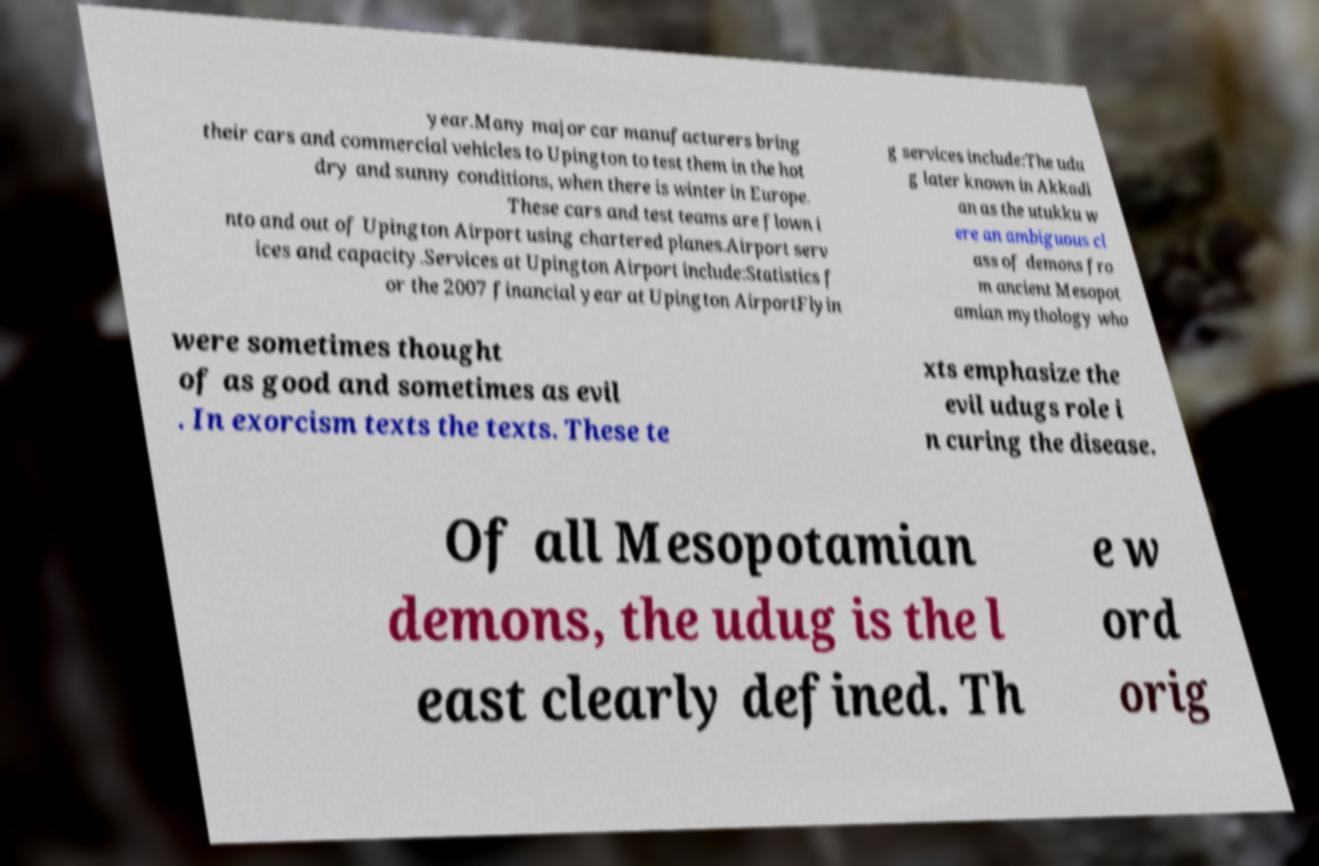For documentation purposes, I need the text within this image transcribed. Could you provide that? year.Many major car manufacturers bring their cars and commercial vehicles to Upington to test them in the hot dry and sunny conditions, when there is winter in Europe. These cars and test teams are flown i nto and out of Upington Airport using chartered planes.Airport serv ices and capacity.Services at Upington Airport include:Statistics f or the 2007 financial year at Upington AirportFlyin g services include:The udu g later known in Akkadi an as the utukku w ere an ambiguous cl ass of demons fro m ancient Mesopot amian mythology who were sometimes thought of as good and sometimes as evil . In exorcism texts the texts. These te xts emphasize the evil udugs role i n curing the disease. Of all Mesopotamian demons, the udug is the l east clearly defined. Th e w ord orig 